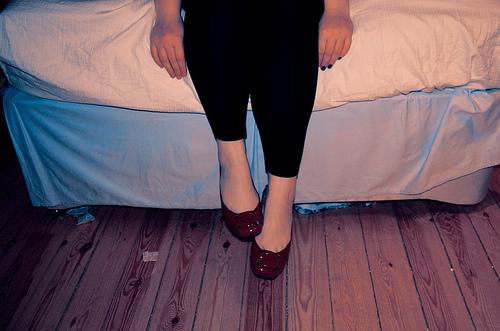What is the bedspread?
Write a very short answer. White. What is she sitting on?
Write a very short answer. Bed. What color are the shoes in this picture?
Concise answer only. Red. 